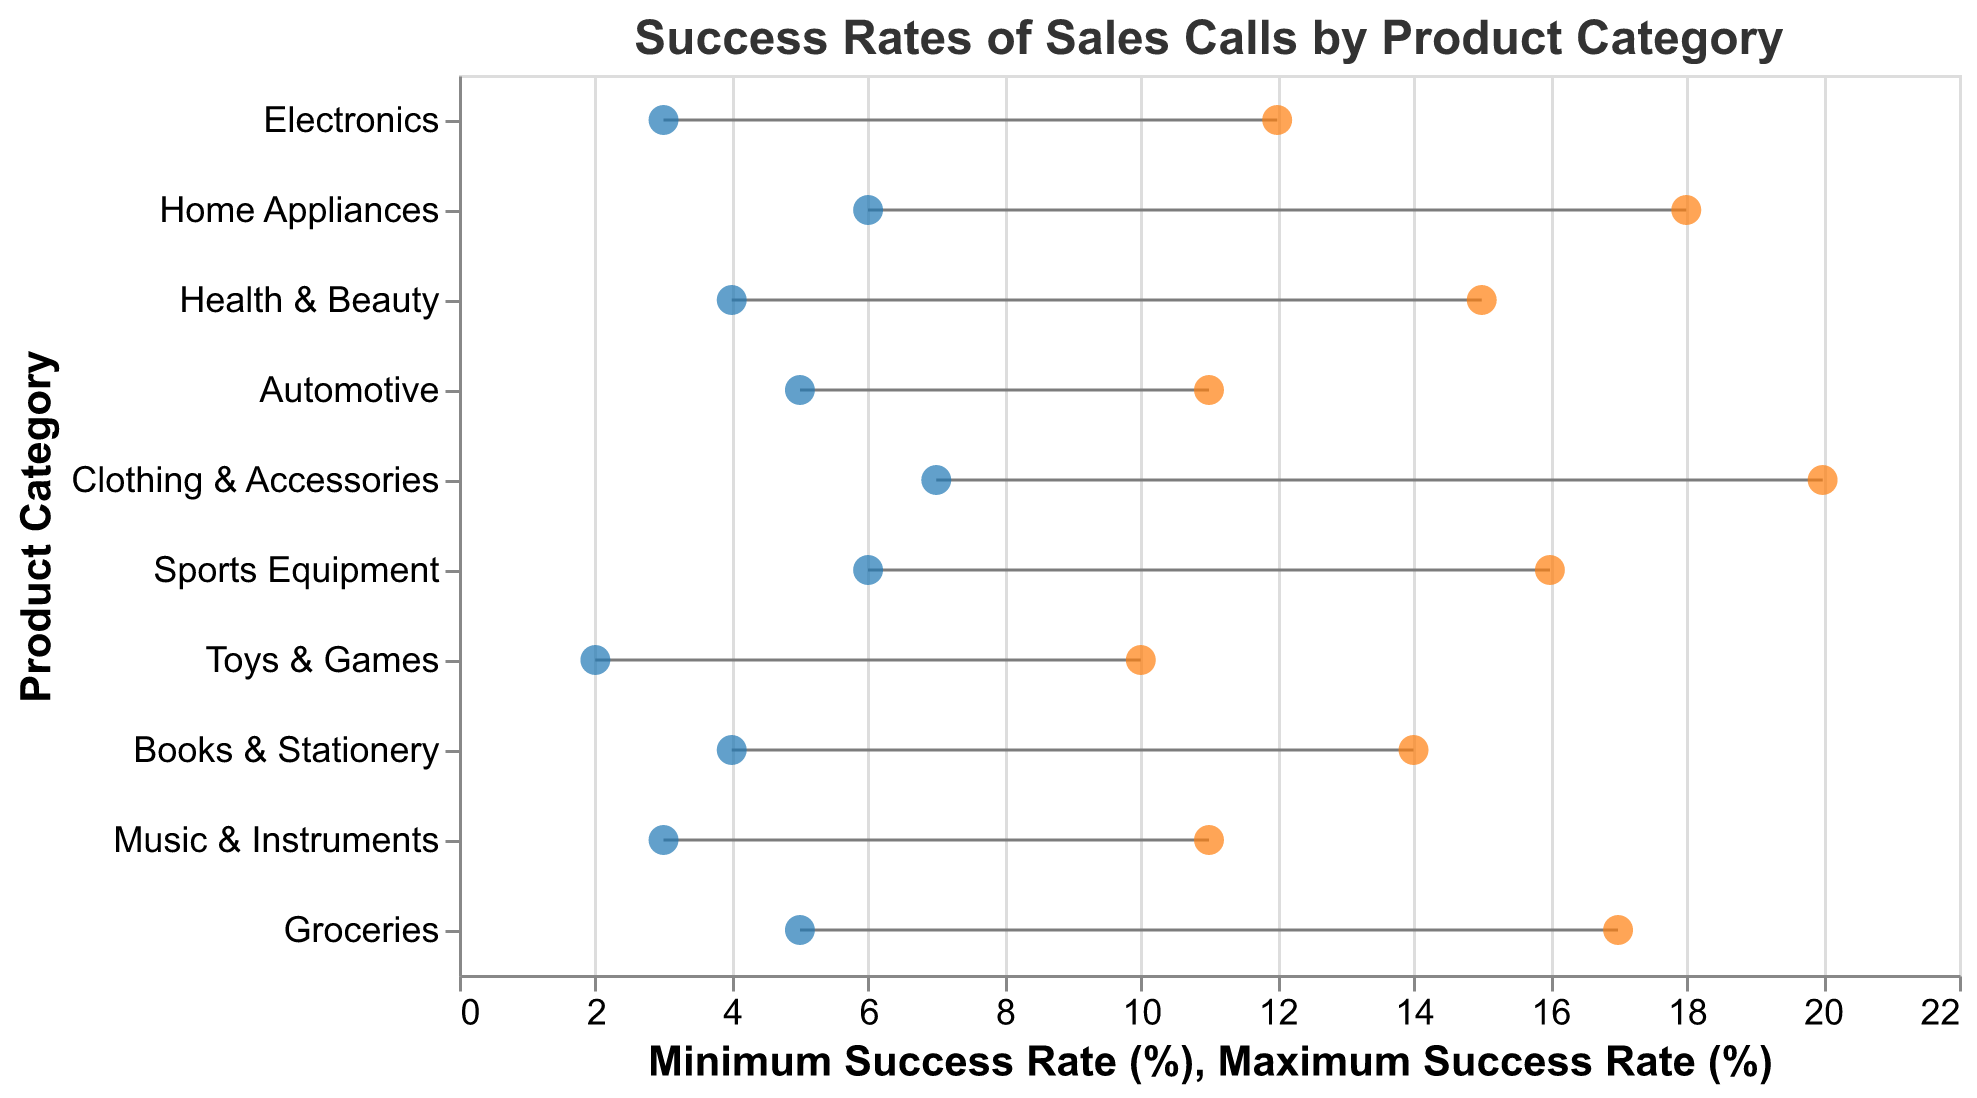How many product categories are depicted in the figure? Count the number of unique product categories listed on the y-axis.
Answer: 10 What is the title of the figure? Read the title text at the top of the figure.
Answer: Success Rates of Sales Calls by Product Category Which product category has the highest maximum success rate? Identify the point with the highest value on the x-axis for maximum success rates and find its corresponding product category on the y-axis.
Answer: Clothing & Accessories What is the range of success rates for Home Appliances? Subtract the minimum success rate from the maximum success rate for the Home Appliances category: 18 - 6.
Answer: 12% Which product category has both the minimum and maximum success rates less than 10%? Check each product category's minimum and maximum success rates, then find the category where both values are below 10%: 2 to 10% for Toys & Games.
Answer: Toys & Games What is the difference between the maximum success rates of Home Appliances and Automotives? Subtract the maximum success rate of Automotives from the maximum success rate of Home Appliances: 18 - 11.
Answer: 7% How many product categories have a minimum success rate above 5%? Count the number of product categories where the minimum success rate value on the x-axis is greater than 5%.
Answer: 5 For which product categories are the success rates closest together? Identify the product category with the smallest difference between minimum and maximum success rates. For Automotive, the difference is 6%: 11 - 5.
Answer: Automotive Which product category showed the largest variation in success rates? Find the category with the widest range between minimum and maximum values. For Clothing & Accessories, the spread is 13%: 20 - 7.
Answer: Clothing & Accessories What is the average maximum success rate across all product categories? Sum up all the maximum success rates and divide by the number of categories: (12 + 18 + 15 + 11 + 20 + 16 + 10 + 14 + 11 + 17) / 10 = 14.4%
Answer: 14.4% 